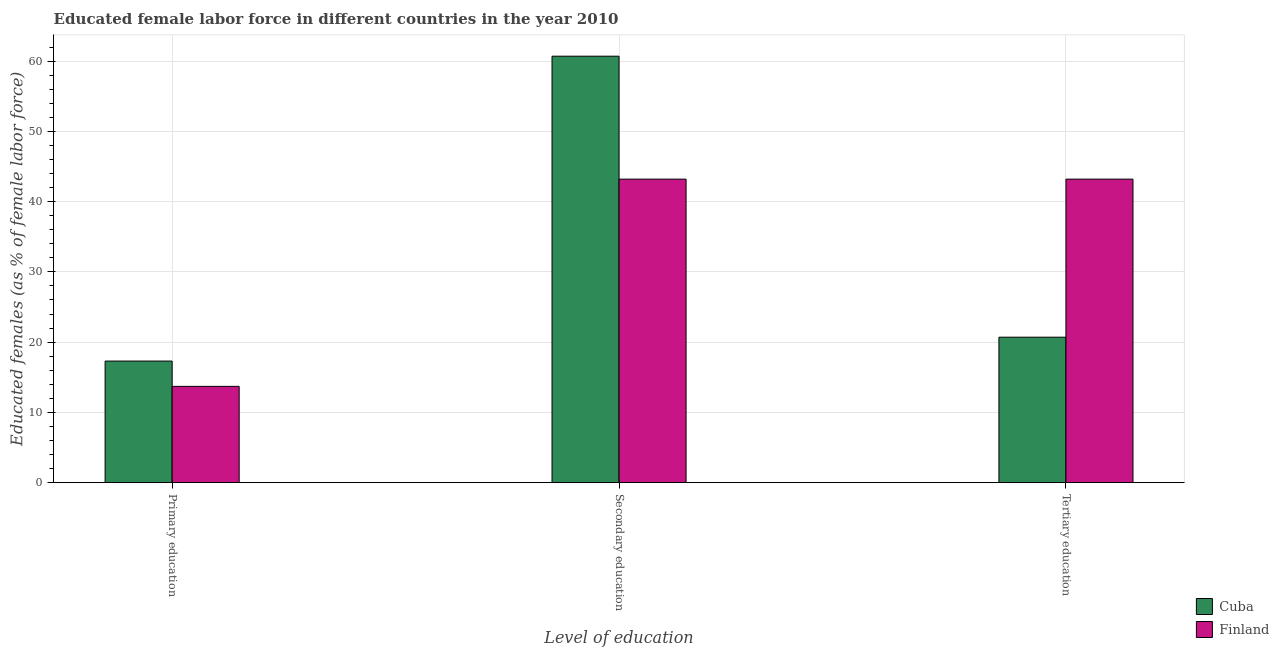How many different coloured bars are there?
Provide a succinct answer. 2. Are the number of bars on each tick of the X-axis equal?
Provide a short and direct response. Yes. How many bars are there on the 3rd tick from the right?
Provide a short and direct response. 2. What is the label of the 1st group of bars from the left?
Offer a very short reply. Primary education. What is the percentage of female labor force who received primary education in Finland?
Make the answer very short. 13.7. Across all countries, what is the maximum percentage of female labor force who received tertiary education?
Your answer should be very brief. 43.2. Across all countries, what is the minimum percentage of female labor force who received tertiary education?
Your answer should be compact. 20.7. In which country was the percentage of female labor force who received primary education maximum?
Ensure brevity in your answer.  Cuba. In which country was the percentage of female labor force who received secondary education minimum?
Offer a terse response. Finland. What is the total percentage of female labor force who received primary education in the graph?
Ensure brevity in your answer.  31. What is the difference between the percentage of female labor force who received tertiary education in Finland and that in Cuba?
Provide a short and direct response. 22.5. What is the average percentage of female labor force who received primary education per country?
Your answer should be compact. 15.5. What is the difference between the percentage of female labor force who received primary education and percentage of female labor force who received secondary education in Finland?
Give a very brief answer. -29.5. What is the ratio of the percentage of female labor force who received tertiary education in Cuba to that in Finland?
Make the answer very short. 0.48. Is the difference between the percentage of female labor force who received primary education in Finland and Cuba greater than the difference between the percentage of female labor force who received secondary education in Finland and Cuba?
Provide a short and direct response. Yes. What is the difference between the highest and the second highest percentage of female labor force who received tertiary education?
Give a very brief answer. 22.5. What is the difference between the highest and the lowest percentage of female labor force who received tertiary education?
Your answer should be compact. 22.5. In how many countries, is the percentage of female labor force who received secondary education greater than the average percentage of female labor force who received secondary education taken over all countries?
Provide a succinct answer. 1. Is the sum of the percentage of female labor force who received tertiary education in Cuba and Finland greater than the maximum percentage of female labor force who received secondary education across all countries?
Make the answer very short. Yes. What does the 1st bar from the left in Secondary education represents?
Offer a very short reply. Cuba. What does the 1st bar from the right in Tertiary education represents?
Your answer should be very brief. Finland. How many bars are there?
Give a very brief answer. 6. Are all the bars in the graph horizontal?
Provide a short and direct response. No. Does the graph contain grids?
Give a very brief answer. Yes. How are the legend labels stacked?
Give a very brief answer. Vertical. What is the title of the graph?
Ensure brevity in your answer.  Educated female labor force in different countries in the year 2010. Does "Norway" appear as one of the legend labels in the graph?
Offer a very short reply. No. What is the label or title of the X-axis?
Provide a short and direct response. Level of education. What is the label or title of the Y-axis?
Provide a succinct answer. Educated females (as % of female labor force). What is the Educated females (as % of female labor force) in Cuba in Primary education?
Give a very brief answer. 17.3. What is the Educated females (as % of female labor force) of Finland in Primary education?
Offer a terse response. 13.7. What is the Educated females (as % of female labor force) in Cuba in Secondary education?
Give a very brief answer. 60.7. What is the Educated females (as % of female labor force) of Finland in Secondary education?
Your response must be concise. 43.2. What is the Educated females (as % of female labor force) of Cuba in Tertiary education?
Give a very brief answer. 20.7. What is the Educated females (as % of female labor force) in Finland in Tertiary education?
Your response must be concise. 43.2. Across all Level of education, what is the maximum Educated females (as % of female labor force) in Cuba?
Make the answer very short. 60.7. Across all Level of education, what is the maximum Educated females (as % of female labor force) of Finland?
Ensure brevity in your answer.  43.2. Across all Level of education, what is the minimum Educated females (as % of female labor force) of Cuba?
Make the answer very short. 17.3. Across all Level of education, what is the minimum Educated females (as % of female labor force) in Finland?
Your answer should be very brief. 13.7. What is the total Educated females (as % of female labor force) of Cuba in the graph?
Make the answer very short. 98.7. What is the total Educated females (as % of female labor force) of Finland in the graph?
Give a very brief answer. 100.1. What is the difference between the Educated females (as % of female labor force) of Cuba in Primary education and that in Secondary education?
Give a very brief answer. -43.4. What is the difference between the Educated females (as % of female labor force) of Finland in Primary education and that in Secondary education?
Provide a short and direct response. -29.5. What is the difference between the Educated females (as % of female labor force) in Finland in Primary education and that in Tertiary education?
Make the answer very short. -29.5. What is the difference between the Educated females (as % of female labor force) of Finland in Secondary education and that in Tertiary education?
Your answer should be very brief. 0. What is the difference between the Educated females (as % of female labor force) of Cuba in Primary education and the Educated females (as % of female labor force) of Finland in Secondary education?
Your answer should be very brief. -25.9. What is the difference between the Educated females (as % of female labor force) in Cuba in Primary education and the Educated females (as % of female labor force) in Finland in Tertiary education?
Your answer should be very brief. -25.9. What is the difference between the Educated females (as % of female labor force) of Cuba in Secondary education and the Educated females (as % of female labor force) of Finland in Tertiary education?
Your answer should be very brief. 17.5. What is the average Educated females (as % of female labor force) of Cuba per Level of education?
Your answer should be compact. 32.9. What is the average Educated females (as % of female labor force) of Finland per Level of education?
Your response must be concise. 33.37. What is the difference between the Educated females (as % of female labor force) of Cuba and Educated females (as % of female labor force) of Finland in Primary education?
Your answer should be compact. 3.6. What is the difference between the Educated females (as % of female labor force) in Cuba and Educated females (as % of female labor force) in Finland in Tertiary education?
Offer a terse response. -22.5. What is the ratio of the Educated females (as % of female labor force) in Cuba in Primary education to that in Secondary education?
Provide a succinct answer. 0.28. What is the ratio of the Educated females (as % of female labor force) of Finland in Primary education to that in Secondary education?
Provide a succinct answer. 0.32. What is the ratio of the Educated females (as % of female labor force) in Cuba in Primary education to that in Tertiary education?
Provide a short and direct response. 0.84. What is the ratio of the Educated females (as % of female labor force) of Finland in Primary education to that in Tertiary education?
Provide a succinct answer. 0.32. What is the ratio of the Educated females (as % of female labor force) of Cuba in Secondary education to that in Tertiary education?
Offer a very short reply. 2.93. What is the ratio of the Educated females (as % of female labor force) of Finland in Secondary education to that in Tertiary education?
Ensure brevity in your answer.  1. What is the difference between the highest and the second highest Educated females (as % of female labor force) of Cuba?
Your answer should be very brief. 40. What is the difference between the highest and the lowest Educated females (as % of female labor force) of Cuba?
Offer a terse response. 43.4. What is the difference between the highest and the lowest Educated females (as % of female labor force) of Finland?
Your answer should be compact. 29.5. 